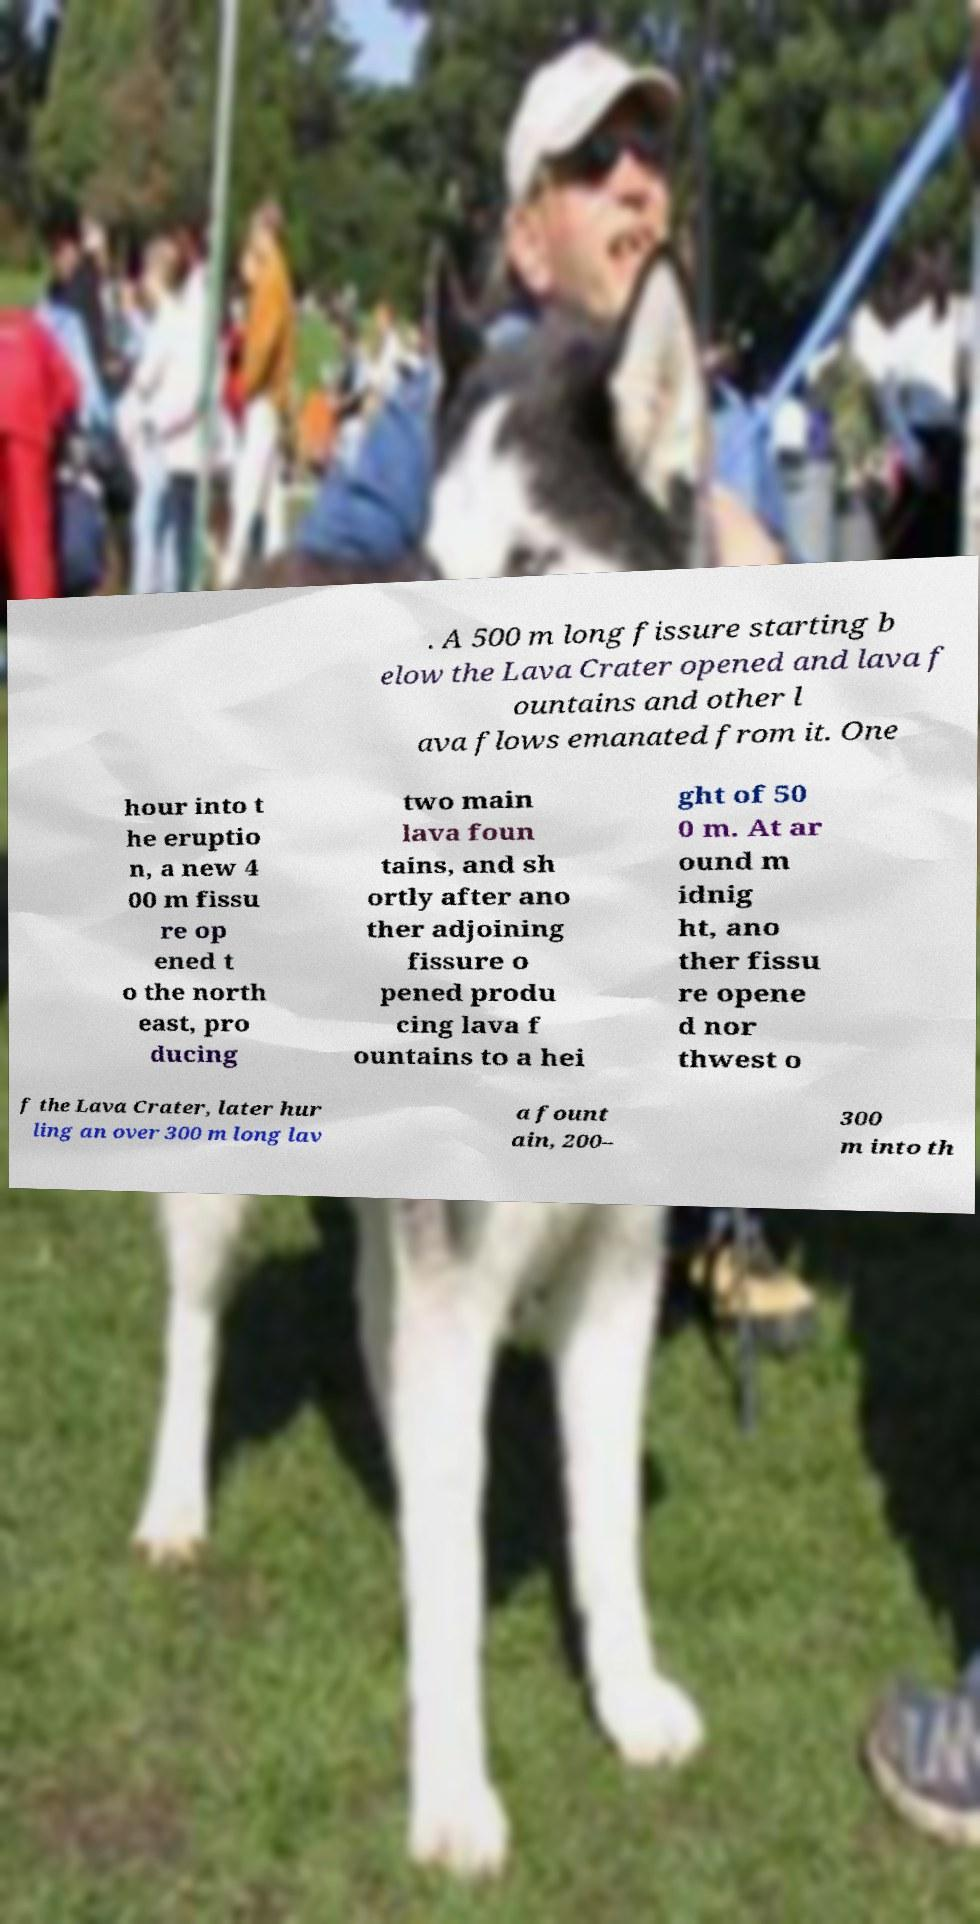Can you read and provide the text displayed in the image?This photo seems to have some interesting text. Can you extract and type it out for me? . A 500 m long fissure starting b elow the Lava Crater opened and lava f ountains and other l ava flows emanated from it. One hour into t he eruptio n, a new 4 00 m fissu re op ened t o the north east, pro ducing two main lava foun tains, and sh ortly after ano ther adjoining fissure o pened produ cing lava f ountains to a hei ght of 50 0 m. At ar ound m idnig ht, ano ther fissu re opene d nor thwest o f the Lava Crater, later hur ling an over 300 m long lav a fount ain, 200– 300 m into th 